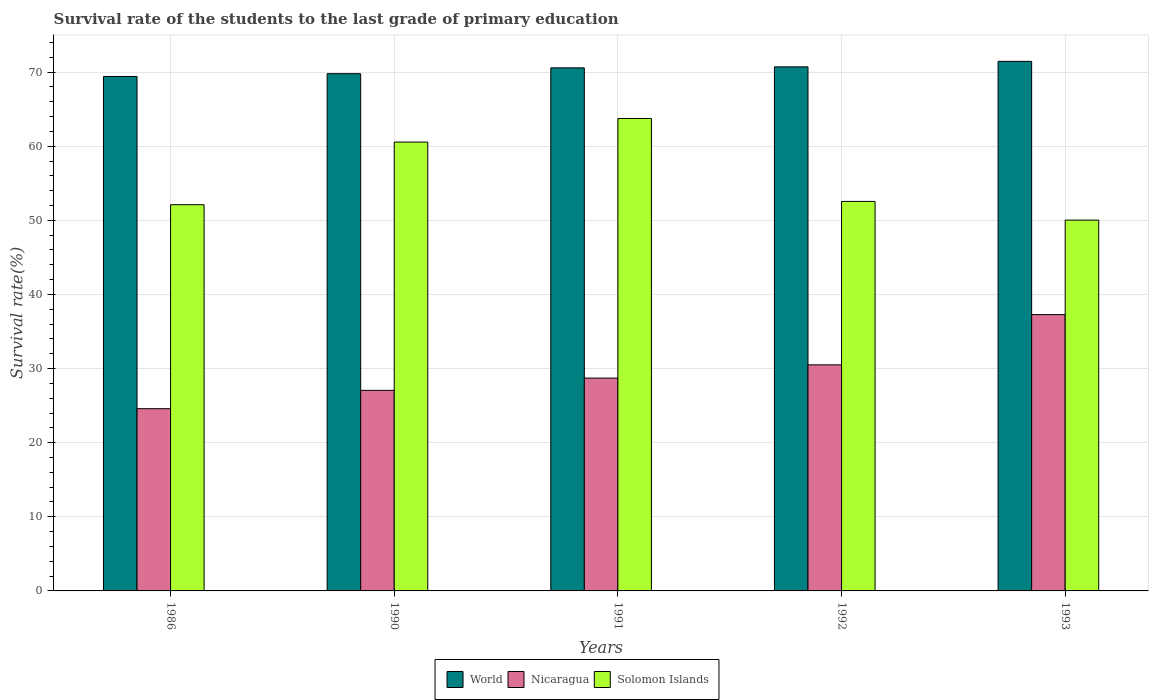How many different coloured bars are there?
Ensure brevity in your answer.  3. Are the number of bars per tick equal to the number of legend labels?
Offer a very short reply. Yes. How many bars are there on the 2nd tick from the left?
Offer a very short reply. 3. What is the label of the 4th group of bars from the left?
Offer a very short reply. 1992. In how many cases, is the number of bars for a given year not equal to the number of legend labels?
Keep it short and to the point. 0. What is the survival rate of the students in World in 1990?
Make the answer very short. 69.78. Across all years, what is the maximum survival rate of the students in Nicaragua?
Make the answer very short. 37.28. Across all years, what is the minimum survival rate of the students in Nicaragua?
Provide a succinct answer. 24.59. In which year was the survival rate of the students in Solomon Islands minimum?
Ensure brevity in your answer.  1993. What is the total survival rate of the students in Solomon Islands in the graph?
Offer a very short reply. 279. What is the difference between the survival rate of the students in World in 1990 and that in 1993?
Make the answer very short. -1.67. What is the difference between the survival rate of the students in Nicaragua in 1993 and the survival rate of the students in World in 1990?
Your answer should be compact. -32.5. What is the average survival rate of the students in Solomon Islands per year?
Provide a short and direct response. 55.8. In the year 1990, what is the difference between the survival rate of the students in Solomon Islands and survival rate of the students in World?
Give a very brief answer. -9.22. What is the ratio of the survival rate of the students in Nicaragua in 1992 to that in 1993?
Ensure brevity in your answer.  0.82. Is the difference between the survival rate of the students in Solomon Islands in 1986 and 1992 greater than the difference between the survival rate of the students in World in 1986 and 1992?
Offer a terse response. Yes. What is the difference between the highest and the second highest survival rate of the students in World?
Make the answer very short. 0.74. What is the difference between the highest and the lowest survival rate of the students in Solomon Islands?
Provide a short and direct response. 13.71. What does the 2nd bar from the left in 1990 represents?
Your answer should be compact. Nicaragua. What does the 3rd bar from the right in 1986 represents?
Give a very brief answer. World. Is it the case that in every year, the sum of the survival rate of the students in World and survival rate of the students in Nicaragua is greater than the survival rate of the students in Solomon Islands?
Give a very brief answer. Yes. How many bars are there?
Give a very brief answer. 15. Are the values on the major ticks of Y-axis written in scientific E-notation?
Your answer should be very brief. No. Where does the legend appear in the graph?
Give a very brief answer. Bottom center. How are the legend labels stacked?
Your answer should be compact. Horizontal. What is the title of the graph?
Ensure brevity in your answer.  Survival rate of the students to the last grade of primary education. What is the label or title of the X-axis?
Give a very brief answer. Years. What is the label or title of the Y-axis?
Keep it short and to the point. Survival rate(%). What is the Survival rate(%) of World in 1986?
Give a very brief answer. 69.41. What is the Survival rate(%) of Nicaragua in 1986?
Provide a succinct answer. 24.59. What is the Survival rate(%) of Solomon Islands in 1986?
Your answer should be compact. 52.11. What is the Survival rate(%) in World in 1990?
Give a very brief answer. 69.78. What is the Survival rate(%) of Nicaragua in 1990?
Keep it short and to the point. 27.06. What is the Survival rate(%) of Solomon Islands in 1990?
Your answer should be compact. 60.56. What is the Survival rate(%) of World in 1991?
Offer a very short reply. 70.57. What is the Survival rate(%) in Nicaragua in 1991?
Give a very brief answer. 28.72. What is the Survival rate(%) of Solomon Islands in 1991?
Offer a very short reply. 63.74. What is the Survival rate(%) of World in 1992?
Offer a very short reply. 70.71. What is the Survival rate(%) in Nicaragua in 1992?
Your answer should be very brief. 30.5. What is the Survival rate(%) of Solomon Islands in 1992?
Your answer should be very brief. 52.55. What is the Survival rate(%) of World in 1993?
Offer a very short reply. 71.45. What is the Survival rate(%) in Nicaragua in 1993?
Your response must be concise. 37.28. What is the Survival rate(%) in Solomon Islands in 1993?
Your answer should be very brief. 50.03. Across all years, what is the maximum Survival rate(%) of World?
Make the answer very short. 71.45. Across all years, what is the maximum Survival rate(%) in Nicaragua?
Give a very brief answer. 37.28. Across all years, what is the maximum Survival rate(%) in Solomon Islands?
Give a very brief answer. 63.74. Across all years, what is the minimum Survival rate(%) in World?
Your answer should be very brief. 69.41. Across all years, what is the minimum Survival rate(%) of Nicaragua?
Give a very brief answer. 24.59. Across all years, what is the minimum Survival rate(%) of Solomon Islands?
Ensure brevity in your answer.  50.03. What is the total Survival rate(%) of World in the graph?
Ensure brevity in your answer.  351.93. What is the total Survival rate(%) in Nicaragua in the graph?
Provide a succinct answer. 148.15. What is the total Survival rate(%) of Solomon Islands in the graph?
Ensure brevity in your answer.  279. What is the difference between the Survival rate(%) in World in 1986 and that in 1990?
Offer a very short reply. -0.37. What is the difference between the Survival rate(%) in Nicaragua in 1986 and that in 1990?
Your response must be concise. -2.47. What is the difference between the Survival rate(%) of Solomon Islands in 1986 and that in 1990?
Your answer should be compact. -8.45. What is the difference between the Survival rate(%) in World in 1986 and that in 1991?
Provide a succinct answer. -1.16. What is the difference between the Survival rate(%) of Nicaragua in 1986 and that in 1991?
Give a very brief answer. -4.13. What is the difference between the Survival rate(%) in Solomon Islands in 1986 and that in 1991?
Your response must be concise. -11.64. What is the difference between the Survival rate(%) in World in 1986 and that in 1992?
Ensure brevity in your answer.  -1.3. What is the difference between the Survival rate(%) of Nicaragua in 1986 and that in 1992?
Keep it short and to the point. -5.91. What is the difference between the Survival rate(%) of Solomon Islands in 1986 and that in 1992?
Your answer should be very brief. -0.44. What is the difference between the Survival rate(%) in World in 1986 and that in 1993?
Provide a short and direct response. -2.04. What is the difference between the Survival rate(%) of Nicaragua in 1986 and that in 1993?
Your answer should be compact. -12.69. What is the difference between the Survival rate(%) in Solomon Islands in 1986 and that in 1993?
Your answer should be very brief. 2.08. What is the difference between the Survival rate(%) in World in 1990 and that in 1991?
Offer a very short reply. -0.79. What is the difference between the Survival rate(%) of Nicaragua in 1990 and that in 1991?
Keep it short and to the point. -1.65. What is the difference between the Survival rate(%) in Solomon Islands in 1990 and that in 1991?
Your answer should be very brief. -3.18. What is the difference between the Survival rate(%) in World in 1990 and that in 1992?
Provide a succinct answer. -0.93. What is the difference between the Survival rate(%) in Nicaragua in 1990 and that in 1992?
Your response must be concise. -3.44. What is the difference between the Survival rate(%) of Solomon Islands in 1990 and that in 1992?
Provide a short and direct response. 8.01. What is the difference between the Survival rate(%) in World in 1990 and that in 1993?
Your answer should be very brief. -1.67. What is the difference between the Survival rate(%) in Nicaragua in 1990 and that in 1993?
Provide a short and direct response. -10.22. What is the difference between the Survival rate(%) in Solomon Islands in 1990 and that in 1993?
Your response must be concise. 10.53. What is the difference between the Survival rate(%) of World in 1991 and that in 1992?
Offer a very short reply. -0.13. What is the difference between the Survival rate(%) in Nicaragua in 1991 and that in 1992?
Your response must be concise. -1.79. What is the difference between the Survival rate(%) in Solomon Islands in 1991 and that in 1992?
Offer a very short reply. 11.19. What is the difference between the Survival rate(%) of World in 1991 and that in 1993?
Your answer should be compact. -0.88. What is the difference between the Survival rate(%) of Nicaragua in 1991 and that in 1993?
Ensure brevity in your answer.  -8.57. What is the difference between the Survival rate(%) of Solomon Islands in 1991 and that in 1993?
Your response must be concise. 13.71. What is the difference between the Survival rate(%) of World in 1992 and that in 1993?
Your answer should be very brief. -0.74. What is the difference between the Survival rate(%) of Nicaragua in 1992 and that in 1993?
Provide a short and direct response. -6.78. What is the difference between the Survival rate(%) of Solomon Islands in 1992 and that in 1993?
Provide a short and direct response. 2.52. What is the difference between the Survival rate(%) in World in 1986 and the Survival rate(%) in Nicaragua in 1990?
Your answer should be very brief. 42.35. What is the difference between the Survival rate(%) in World in 1986 and the Survival rate(%) in Solomon Islands in 1990?
Offer a very short reply. 8.85. What is the difference between the Survival rate(%) in Nicaragua in 1986 and the Survival rate(%) in Solomon Islands in 1990?
Make the answer very short. -35.97. What is the difference between the Survival rate(%) of World in 1986 and the Survival rate(%) of Nicaragua in 1991?
Give a very brief answer. 40.69. What is the difference between the Survival rate(%) in World in 1986 and the Survival rate(%) in Solomon Islands in 1991?
Offer a very short reply. 5.67. What is the difference between the Survival rate(%) of Nicaragua in 1986 and the Survival rate(%) of Solomon Islands in 1991?
Offer a very short reply. -39.16. What is the difference between the Survival rate(%) of World in 1986 and the Survival rate(%) of Nicaragua in 1992?
Your response must be concise. 38.91. What is the difference between the Survival rate(%) of World in 1986 and the Survival rate(%) of Solomon Islands in 1992?
Offer a terse response. 16.86. What is the difference between the Survival rate(%) of Nicaragua in 1986 and the Survival rate(%) of Solomon Islands in 1992?
Offer a very short reply. -27.97. What is the difference between the Survival rate(%) of World in 1986 and the Survival rate(%) of Nicaragua in 1993?
Make the answer very short. 32.13. What is the difference between the Survival rate(%) of World in 1986 and the Survival rate(%) of Solomon Islands in 1993?
Provide a short and direct response. 19.38. What is the difference between the Survival rate(%) of Nicaragua in 1986 and the Survival rate(%) of Solomon Islands in 1993?
Provide a short and direct response. -25.44. What is the difference between the Survival rate(%) of World in 1990 and the Survival rate(%) of Nicaragua in 1991?
Your answer should be compact. 41.07. What is the difference between the Survival rate(%) in World in 1990 and the Survival rate(%) in Solomon Islands in 1991?
Make the answer very short. 6.04. What is the difference between the Survival rate(%) in Nicaragua in 1990 and the Survival rate(%) in Solomon Islands in 1991?
Your answer should be very brief. -36.68. What is the difference between the Survival rate(%) of World in 1990 and the Survival rate(%) of Nicaragua in 1992?
Offer a very short reply. 39.28. What is the difference between the Survival rate(%) in World in 1990 and the Survival rate(%) in Solomon Islands in 1992?
Keep it short and to the point. 17.23. What is the difference between the Survival rate(%) in Nicaragua in 1990 and the Survival rate(%) in Solomon Islands in 1992?
Provide a short and direct response. -25.49. What is the difference between the Survival rate(%) in World in 1990 and the Survival rate(%) in Nicaragua in 1993?
Your answer should be very brief. 32.5. What is the difference between the Survival rate(%) in World in 1990 and the Survival rate(%) in Solomon Islands in 1993?
Make the answer very short. 19.75. What is the difference between the Survival rate(%) in Nicaragua in 1990 and the Survival rate(%) in Solomon Islands in 1993?
Your response must be concise. -22.97. What is the difference between the Survival rate(%) in World in 1991 and the Survival rate(%) in Nicaragua in 1992?
Give a very brief answer. 40.07. What is the difference between the Survival rate(%) in World in 1991 and the Survival rate(%) in Solomon Islands in 1992?
Your response must be concise. 18.02. What is the difference between the Survival rate(%) of Nicaragua in 1991 and the Survival rate(%) of Solomon Islands in 1992?
Your response must be concise. -23.84. What is the difference between the Survival rate(%) in World in 1991 and the Survival rate(%) in Nicaragua in 1993?
Give a very brief answer. 33.29. What is the difference between the Survival rate(%) in World in 1991 and the Survival rate(%) in Solomon Islands in 1993?
Your answer should be compact. 20.54. What is the difference between the Survival rate(%) in Nicaragua in 1991 and the Survival rate(%) in Solomon Islands in 1993?
Your answer should be compact. -21.32. What is the difference between the Survival rate(%) of World in 1992 and the Survival rate(%) of Nicaragua in 1993?
Your answer should be compact. 33.43. What is the difference between the Survival rate(%) of World in 1992 and the Survival rate(%) of Solomon Islands in 1993?
Make the answer very short. 20.68. What is the difference between the Survival rate(%) in Nicaragua in 1992 and the Survival rate(%) in Solomon Islands in 1993?
Your response must be concise. -19.53. What is the average Survival rate(%) of World per year?
Give a very brief answer. 70.39. What is the average Survival rate(%) in Nicaragua per year?
Offer a very short reply. 29.63. What is the average Survival rate(%) in Solomon Islands per year?
Your answer should be very brief. 55.8. In the year 1986, what is the difference between the Survival rate(%) in World and Survival rate(%) in Nicaragua?
Keep it short and to the point. 44.82. In the year 1986, what is the difference between the Survival rate(%) of World and Survival rate(%) of Solomon Islands?
Give a very brief answer. 17.3. In the year 1986, what is the difference between the Survival rate(%) in Nicaragua and Survival rate(%) in Solomon Islands?
Your answer should be compact. -27.52. In the year 1990, what is the difference between the Survival rate(%) of World and Survival rate(%) of Nicaragua?
Ensure brevity in your answer.  42.72. In the year 1990, what is the difference between the Survival rate(%) of World and Survival rate(%) of Solomon Islands?
Make the answer very short. 9.22. In the year 1990, what is the difference between the Survival rate(%) in Nicaragua and Survival rate(%) in Solomon Islands?
Offer a very short reply. -33.5. In the year 1991, what is the difference between the Survival rate(%) in World and Survival rate(%) in Nicaragua?
Provide a succinct answer. 41.86. In the year 1991, what is the difference between the Survival rate(%) in World and Survival rate(%) in Solomon Islands?
Offer a terse response. 6.83. In the year 1991, what is the difference between the Survival rate(%) in Nicaragua and Survival rate(%) in Solomon Islands?
Keep it short and to the point. -35.03. In the year 1992, what is the difference between the Survival rate(%) of World and Survival rate(%) of Nicaragua?
Offer a very short reply. 40.21. In the year 1992, what is the difference between the Survival rate(%) of World and Survival rate(%) of Solomon Islands?
Ensure brevity in your answer.  18.15. In the year 1992, what is the difference between the Survival rate(%) of Nicaragua and Survival rate(%) of Solomon Islands?
Make the answer very short. -22.05. In the year 1993, what is the difference between the Survival rate(%) of World and Survival rate(%) of Nicaragua?
Offer a very short reply. 34.17. In the year 1993, what is the difference between the Survival rate(%) of World and Survival rate(%) of Solomon Islands?
Offer a very short reply. 21.42. In the year 1993, what is the difference between the Survival rate(%) of Nicaragua and Survival rate(%) of Solomon Islands?
Offer a very short reply. -12.75. What is the ratio of the Survival rate(%) of Nicaragua in 1986 to that in 1990?
Make the answer very short. 0.91. What is the ratio of the Survival rate(%) of Solomon Islands in 1986 to that in 1990?
Ensure brevity in your answer.  0.86. What is the ratio of the Survival rate(%) of World in 1986 to that in 1991?
Offer a very short reply. 0.98. What is the ratio of the Survival rate(%) of Nicaragua in 1986 to that in 1991?
Give a very brief answer. 0.86. What is the ratio of the Survival rate(%) in Solomon Islands in 1986 to that in 1991?
Provide a short and direct response. 0.82. What is the ratio of the Survival rate(%) of World in 1986 to that in 1992?
Your answer should be compact. 0.98. What is the ratio of the Survival rate(%) of Nicaragua in 1986 to that in 1992?
Make the answer very short. 0.81. What is the ratio of the Survival rate(%) of World in 1986 to that in 1993?
Give a very brief answer. 0.97. What is the ratio of the Survival rate(%) of Nicaragua in 1986 to that in 1993?
Provide a short and direct response. 0.66. What is the ratio of the Survival rate(%) in Solomon Islands in 1986 to that in 1993?
Provide a short and direct response. 1.04. What is the ratio of the Survival rate(%) in World in 1990 to that in 1991?
Your answer should be compact. 0.99. What is the ratio of the Survival rate(%) of Nicaragua in 1990 to that in 1991?
Ensure brevity in your answer.  0.94. What is the ratio of the Survival rate(%) in Solomon Islands in 1990 to that in 1991?
Offer a terse response. 0.95. What is the ratio of the Survival rate(%) in World in 1990 to that in 1992?
Offer a terse response. 0.99. What is the ratio of the Survival rate(%) in Nicaragua in 1990 to that in 1992?
Keep it short and to the point. 0.89. What is the ratio of the Survival rate(%) of Solomon Islands in 1990 to that in 1992?
Give a very brief answer. 1.15. What is the ratio of the Survival rate(%) of World in 1990 to that in 1993?
Your answer should be very brief. 0.98. What is the ratio of the Survival rate(%) of Nicaragua in 1990 to that in 1993?
Offer a terse response. 0.73. What is the ratio of the Survival rate(%) in Solomon Islands in 1990 to that in 1993?
Your answer should be compact. 1.21. What is the ratio of the Survival rate(%) in World in 1991 to that in 1992?
Keep it short and to the point. 1. What is the ratio of the Survival rate(%) of Nicaragua in 1991 to that in 1992?
Give a very brief answer. 0.94. What is the ratio of the Survival rate(%) of Solomon Islands in 1991 to that in 1992?
Make the answer very short. 1.21. What is the ratio of the Survival rate(%) in Nicaragua in 1991 to that in 1993?
Your answer should be compact. 0.77. What is the ratio of the Survival rate(%) in Solomon Islands in 1991 to that in 1993?
Ensure brevity in your answer.  1.27. What is the ratio of the Survival rate(%) in Nicaragua in 1992 to that in 1993?
Give a very brief answer. 0.82. What is the ratio of the Survival rate(%) of Solomon Islands in 1992 to that in 1993?
Provide a succinct answer. 1.05. What is the difference between the highest and the second highest Survival rate(%) of World?
Ensure brevity in your answer.  0.74. What is the difference between the highest and the second highest Survival rate(%) in Nicaragua?
Give a very brief answer. 6.78. What is the difference between the highest and the second highest Survival rate(%) in Solomon Islands?
Make the answer very short. 3.18. What is the difference between the highest and the lowest Survival rate(%) of World?
Your answer should be very brief. 2.04. What is the difference between the highest and the lowest Survival rate(%) in Nicaragua?
Give a very brief answer. 12.69. What is the difference between the highest and the lowest Survival rate(%) of Solomon Islands?
Your response must be concise. 13.71. 